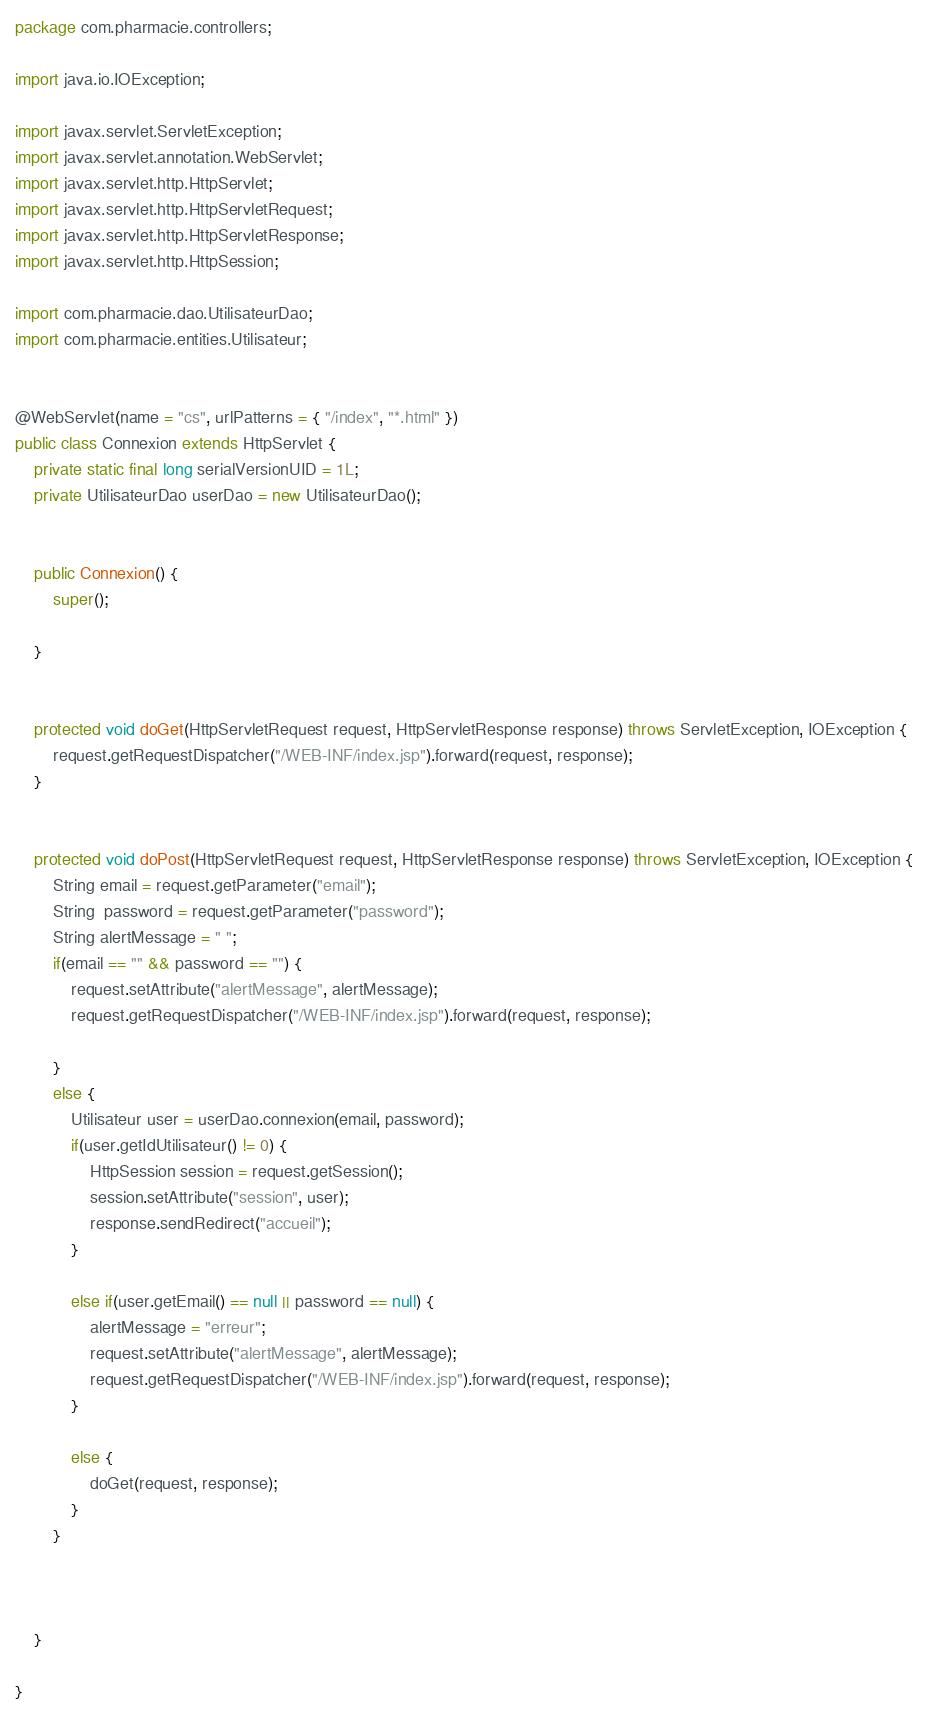<code> <loc_0><loc_0><loc_500><loc_500><_Java_>package com.pharmacie.controllers;

import java.io.IOException;

import javax.servlet.ServletException;
import javax.servlet.annotation.WebServlet;
import javax.servlet.http.HttpServlet;
import javax.servlet.http.HttpServletRequest;
import javax.servlet.http.HttpServletResponse;
import javax.servlet.http.HttpSession;

import com.pharmacie.dao.UtilisateurDao;
import com.pharmacie.entities.Utilisateur;


@WebServlet(name = "cs", urlPatterns = { "/index", "*.html" })
public class Connexion extends HttpServlet {
	private static final long serialVersionUID = 1L;
	private UtilisateurDao userDao = new UtilisateurDao();
       
    
    public Connexion() {
        super();
        
    }

	
	protected void doGet(HttpServletRequest request, HttpServletResponse response) throws ServletException, IOException {
		request.getRequestDispatcher("/WEB-INF/index.jsp").forward(request, response);
	}

	
	protected void doPost(HttpServletRequest request, HttpServletResponse response) throws ServletException, IOException {
		String email = request.getParameter("email");
		String  password = request.getParameter("password");
		String alertMessage = " ";
		if(email == "" && password == "") {
			request.setAttribute("alertMessage", alertMessage);
			request.getRequestDispatcher("/WEB-INF/index.jsp").forward(request, response);
			
		}
		else {
			Utilisateur user = userDao.connexion(email, password);
			if(user.getIdUtilisateur() != 0) {
				HttpSession session = request.getSession();
				session.setAttribute("session", user);
				response.sendRedirect("accueil");
			}
			
			else if(user.getEmail() == null || password == null) {
				alertMessage = "erreur";
				request.setAttribute("alertMessage", alertMessage);
				request.getRequestDispatcher("/WEB-INF/index.jsp").forward(request, response);
			}
			
			else {
				doGet(request, response);
			}
		}
		
		
		
	}

}
</code> 